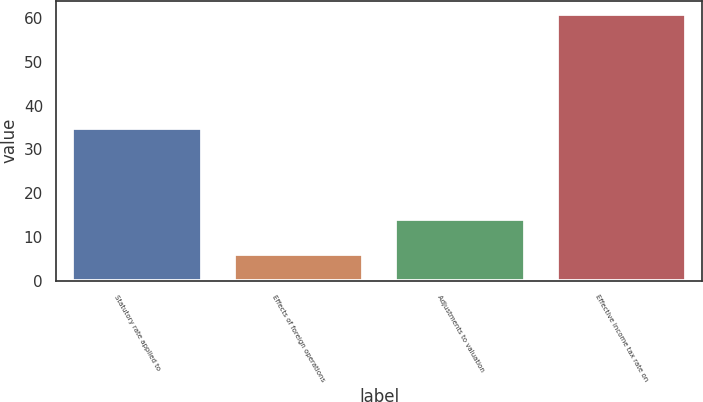<chart> <loc_0><loc_0><loc_500><loc_500><bar_chart><fcel>Statutory rate applied to<fcel>Effects of foreign operations<fcel>Adjustments to valuation<fcel>Effective income tax rate on<nl><fcel>35<fcel>6<fcel>14<fcel>61<nl></chart> 